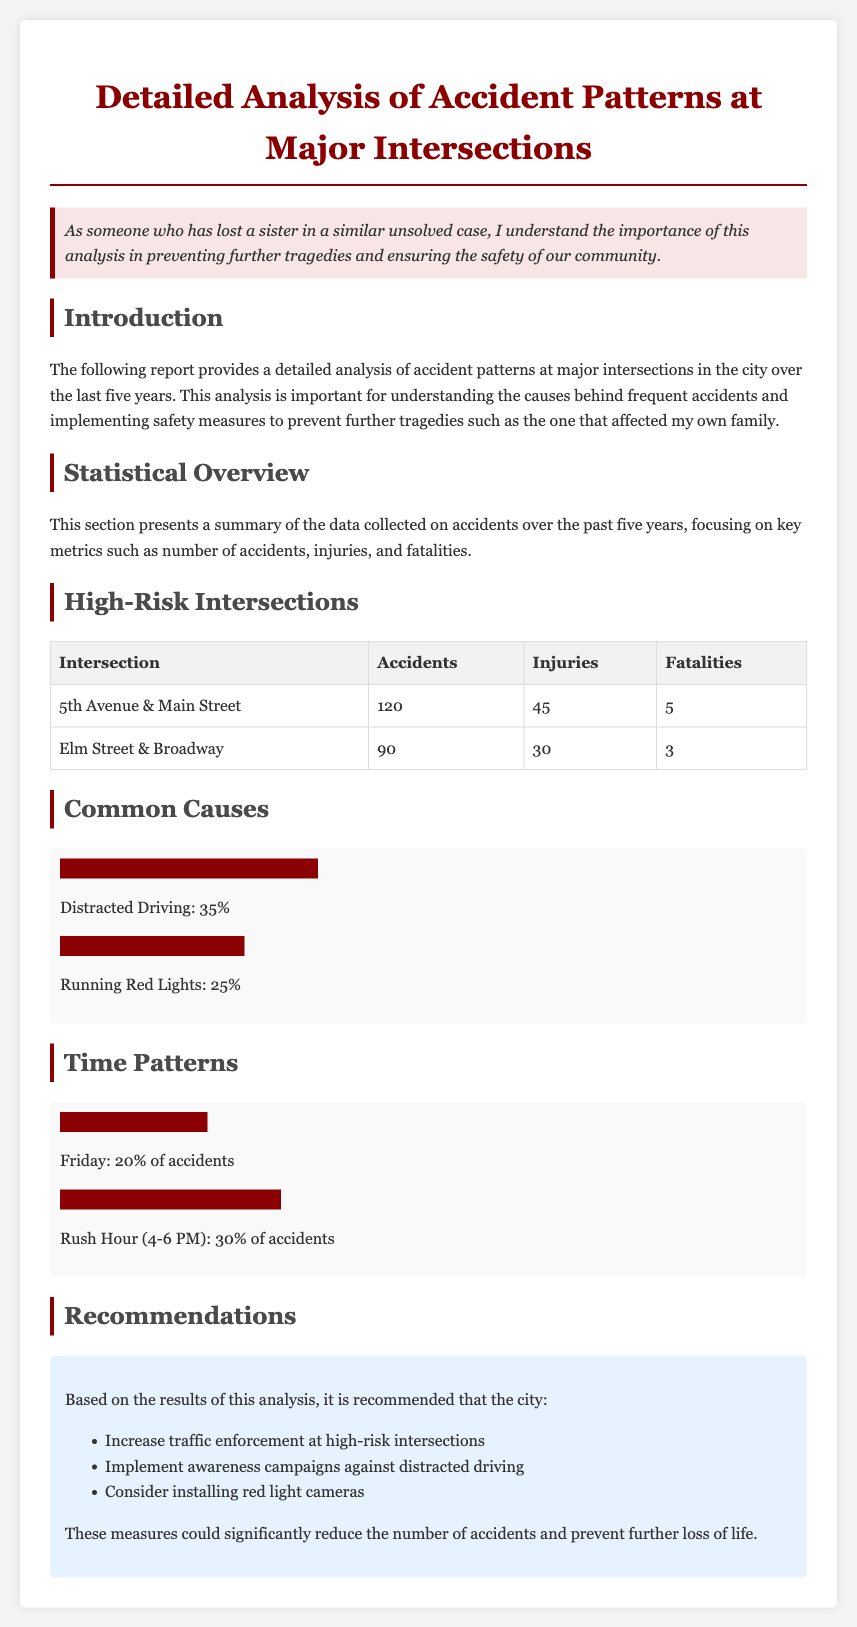What is the title of the report? The title is stated at the top of the document, which details the focus of the analysis.
Answer: Detailed Analysis of Accident Patterns at Major Intersections How many accidents occurred at 5th Avenue & Main Street? The number of accidents is provided in the statistical overview table for that intersection.
Answer: 120 What percentage of accidents is due to distracted driving? The document includes specific percentages for the causes of accidents in the common causes section.
Answer: 35% Which day of the week has the highest accident percentage? The time patterns section indicates which day contributes significantly to the accidents.
Answer: Friday What are the recommended actions to improve safety? Recommendations are given in the report based on the analytical results.
Answer: Increase traffic enforcement at high-risk intersections How many fatalities occurred at Elm Street & Broadway? The statistical overview table provides the number of fatalities for this intersection.
Answer: 3 What time period sees the highest percentage of accidents? The time patterns section discusses specific times that correlate with a high percentage of accidents.
Answer: Rush Hour (4-6 PM) What is the total number of injuries reported at major intersections? While the document provides specific statistics for two intersections, a sum needs to be calculated.
Answer: 75 